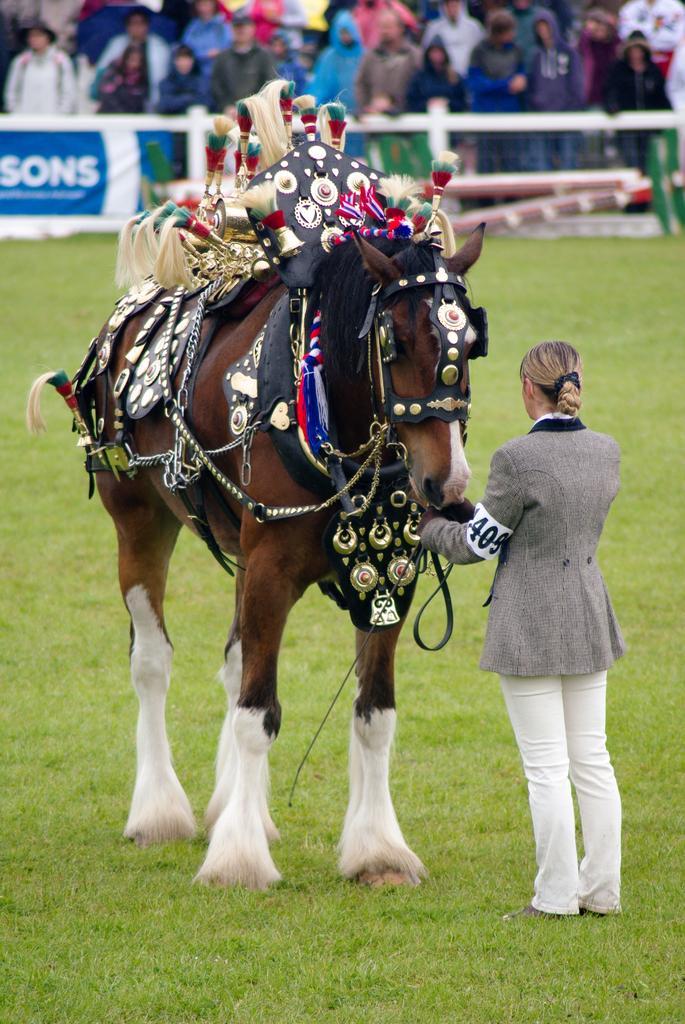How would you summarize this image in a sentence or two? This Picture describe about the horse who is well decorated with bells and ribbons on him and woman wearing grey coat and white pant holding the horse rope. And in behind the public crowd is watching them 